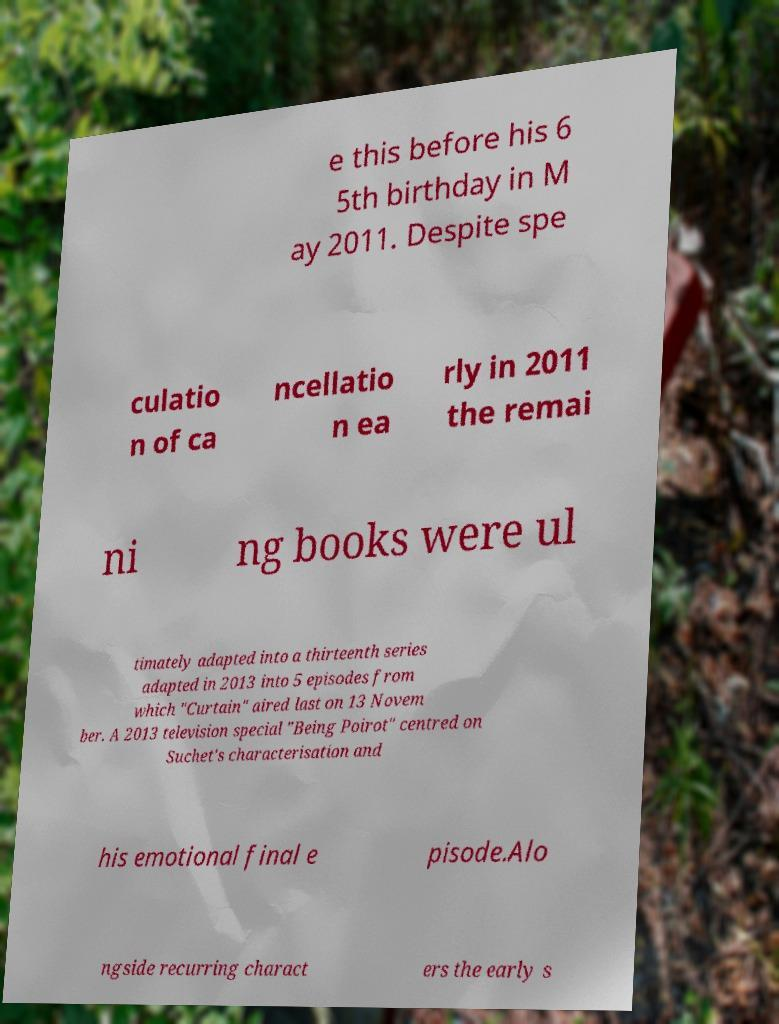I need the written content from this picture converted into text. Can you do that? e this before his 6 5th birthday in M ay 2011. Despite spe culatio n of ca ncellatio n ea rly in 2011 the remai ni ng books were ul timately adapted into a thirteenth series adapted in 2013 into 5 episodes from which "Curtain" aired last on 13 Novem ber. A 2013 television special "Being Poirot" centred on Suchet's characterisation and his emotional final e pisode.Alo ngside recurring charact ers the early s 